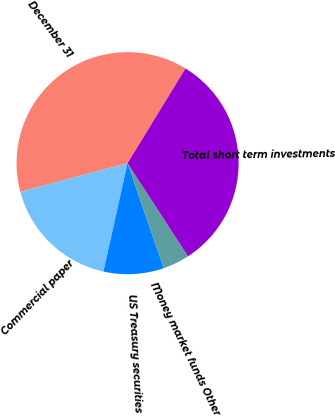Convert chart. <chart><loc_0><loc_0><loc_500><loc_500><pie_chart><fcel>December 31<fcel>Commercial paper<fcel>US Treasury securities<fcel>Money market funds Other<fcel>Total short term investments<nl><fcel>37.9%<fcel>17.35%<fcel>8.77%<fcel>3.88%<fcel>32.1%<nl></chart> 